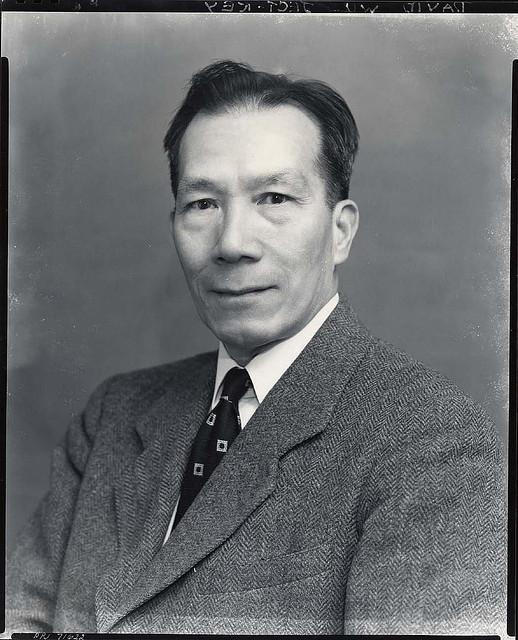How many stripes are on the man's necktie?
Give a very brief answer. 0. How many people are there?
Give a very brief answer. 1. How many us airways express airplanes are in this image?
Give a very brief answer. 0. 